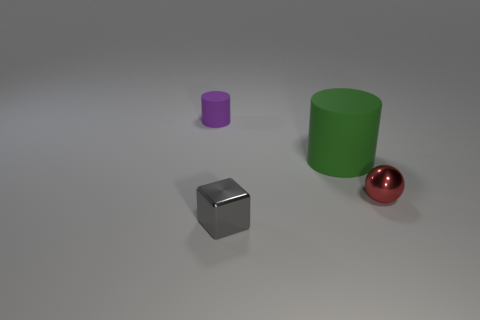Add 2 green cylinders. How many objects exist? 6 Subtract all blocks. How many objects are left? 3 Add 4 big red shiny things. How many big red shiny things exist? 4 Subtract 0 brown cubes. How many objects are left? 4 Subtract all big purple cylinders. Subtract all small rubber objects. How many objects are left? 3 Add 4 tiny shiny blocks. How many tiny shiny blocks are left? 5 